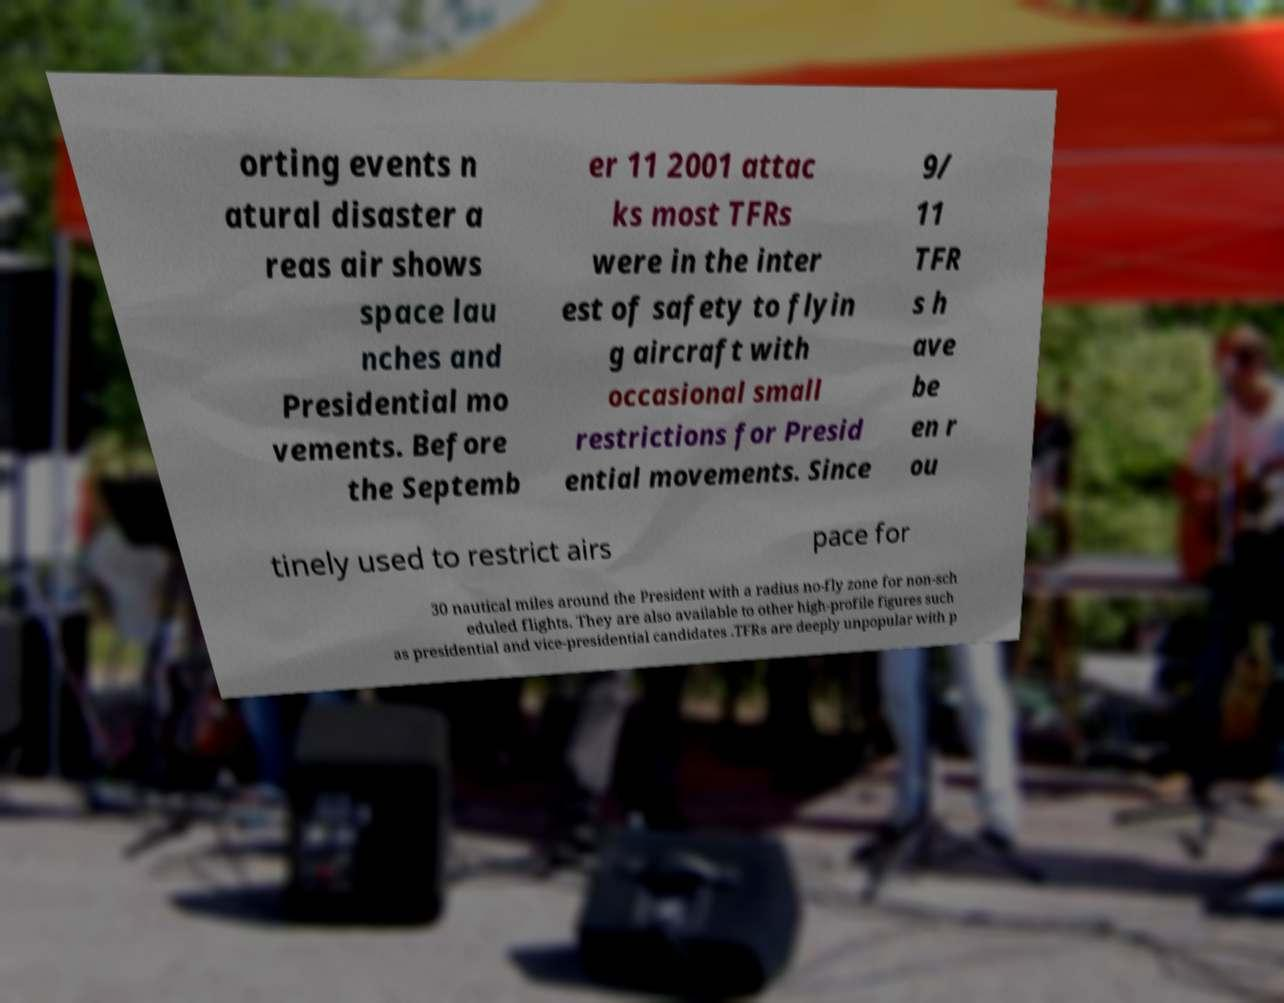Please identify and transcribe the text found in this image. orting events n atural disaster a reas air shows space lau nches and Presidential mo vements. Before the Septemb er 11 2001 attac ks most TFRs were in the inter est of safety to flyin g aircraft with occasional small restrictions for Presid ential movements. Since 9/ 11 TFR s h ave be en r ou tinely used to restrict airs pace for 30 nautical miles around the President with a radius no-fly zone for non-sch eduled flights. They are also available to other high-profile figures such as presidential and vice-presidential candidates .TFRs are deeply unpopular with p 